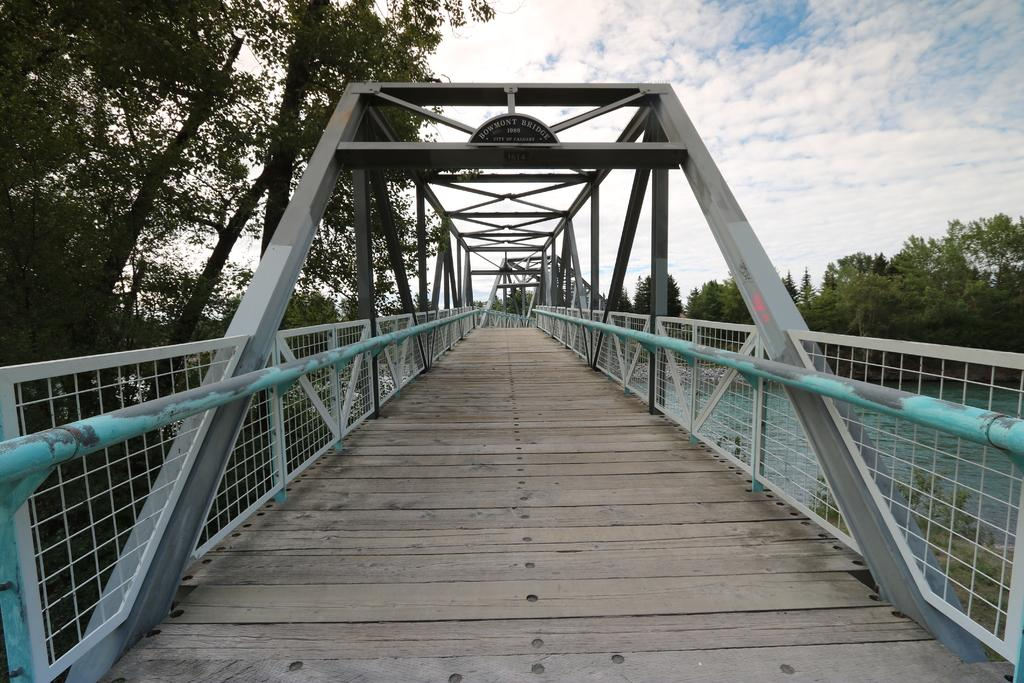What is the main structure visible in the foreground of the image? There is a bridge in the foreground of the image. What type of vegetation can be seen in the background of the image? There are trees in the background of the image. What natural element is visible in the background of the image? There is water visible in the background of the image. What else can be seen in the background of the image? The sky is visible in the background of the image. What type of cabbage is being used to protest in the image? There is no cabbage or protest present in the image. How hot is the water visible in the background of the image? The temperature of the water is not mentioned in the image, and therefore it cannot be determined. 